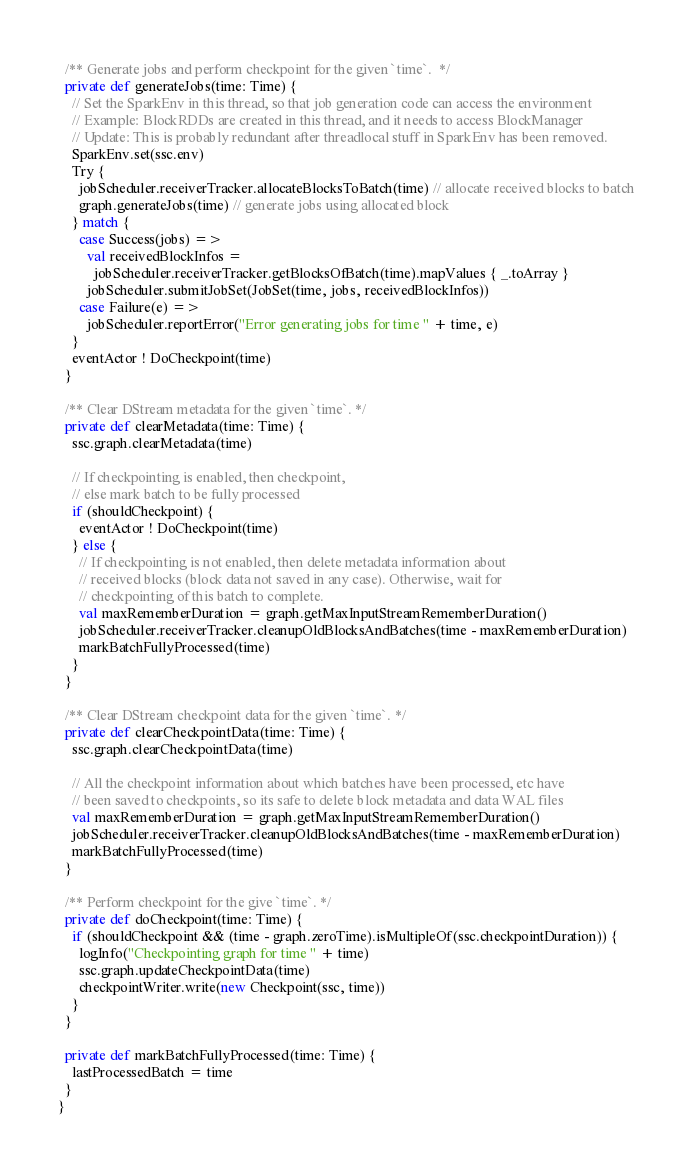<code> <loc_0><loc_0><loc_500><loc_500><_Scala_>
  /** Generate jobs and perform checkpoint for the given `time`.  */
  private def generateJobs(time: Time) {
    // Set the SparkEnv in this thread, so that job generation code can access the environment
    // Example: BlockRDDs are created in this thread, and it needs to access BlockManager
    // Update: This is probably redundant after threadlocal stuff in SparkEnv has been removed.
    SparkEnv.set(ssc.env)
    Try {
      jobScheduler.receiverTracker.allocateBlocksToBatch(time) // allocate received blocks to batch
      graph.generateJobs(time) // generate jobs using allocated block
    } match {
      case Success(jobs) =>
        val receivedBlockInfos =
          jobScheduler.receiverTracker.getBlocksOfBatch(time).mapValues { _.toArray }
        jobScheduler.submitJobSet(JobSet(time, jobs, receivedBlockInfos))
      case Failure(e) =>
        jobScheduler.reportError("Error generating jobs for time " + time, e)
    }
    eventActor ! DoCheckpoint(time)
  }

  /** Clear DStream metadata for the given `time`. */
  private def clearMetadata(time: Time) {
    ssc.graph.clearMetadata(time)

    // If checkpointing is enabled, then checkpoint,
    // else mark batch to be fully processed
    if (shouldCheckpoint) {
      eventActor ! DoCheckpoint(time)
    } else {
      // If checkpointing is not enabled, then delete metadata information about
      // received blocks (block data not saved in any case). Otherwise, wait for
      // checkpointing of this batch to complete.
      val maxRememberDuration = graph.getMaxInputStreamRememberDuration()
      jobScheduler.receiverTracker.cleanupOldBlocksAndBatches(time - maxRememberDuration)
      markBatchFullyProcessed(time)
    }
  }

  /** Clear DStream checkpoint data for the given `time`. */
  private def clearCheckpointData(time: Time) {
    ssc.graph.clearCheckpointData(time)

    // All the checkpoint information about which batches have been processed, etc have
    // been saved to checkpoints, so its safe to delete block metadata and data WAL files
    val maxRememberDuration = graph.getMaxInputStreamRememberDuration()
    jobScheduler.receiverTracker.cleanupOldBlocksAndBatches(time - maxRememberDuration)
    markBatchFullyProcessed(time)
  }

  /** Perform checkpoint for the give `time`. */
  private def doCheckpoint(time: Time) {
    if (shouldCheckpoint && (time - graph.zeroTime).isMultipleOf(ssc.checkpointDuration)) {
      logInfo("Checkpointing graph for time " + time)
      ssc.graph.updateCheckpointData(time)
      checkpointWriter.write(new Checkpoint(ssc, time))
    }
  }

  private def markBatchFullyProcessed(time: Time) {
    lastProcessedBatch = time
  }
}
</code> 